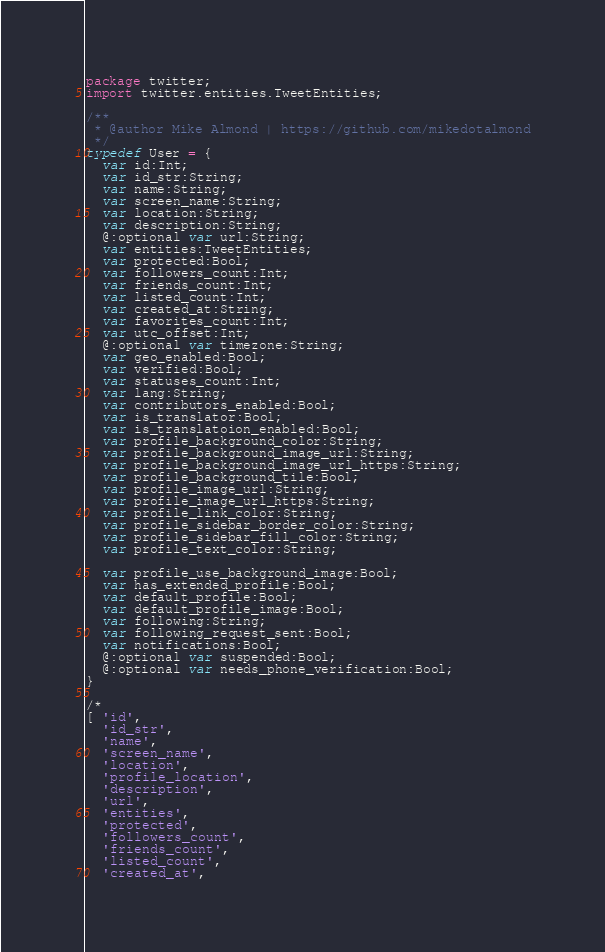<code> <loc_0><loc_0><loc_500><loc_500><_Haxe_>package twitter;
import twitter.entities.TweetEntities;

/**
 * @author Mike Almond | https://github.com/mikedotalmond
 */
typedef User = {
  var id:Int;
  var id_str:String;
  var name:String;
  var screen_name:String;
  var location:String;
  var description:String;
  @:optional var url:String;
  var entities:TweetEntities;
  var protected:Bool;
  var followers_count:Int;
  var friends_count:Int;
  var listed_count:Int;
  var created_at:String;
  var favorites_count:Int;
  var utc_offset:Int;
  @:optional var timezone:String;
  var geo_enabled:Bool;
  var verified:Bool;
  var statuses_count:Int;
  var lang:String;
  var contributors_enabled:Bool;
  var is_translator:Bool;
  var is_translatoion_enabled:Bool;
  var profile_background_color:String;
  var profile_background_image_url:String;
  var profile_background_image_url_https:String;
  var profile_background_tile:Bool;
  var profile_image_url:String;
  var profile_image_url_https:String;
  var profile_link_color:String;
  var profile_sidebar_border_color:String;
  var profile_sidebar_fill_color:String;
  var profile_text_color:String;
	
  var profile_use_background_image:Bool;
  var has_extended_profile:Bool;
  var default_profile:Bool;
  var default_profile_image:Bool;
  var following:String;
  var following_request_sent:Bool;
  var notifications:Bool;
  @:optional var suspended:Bool;
  @:optional var needs_phone_verification:Bool;
}

/*
[ 'id',
  'id_str',
  'name',
  'screen_name',
  'location',
  'profile_location',
  'description',
  'url',
  'entities',
  'protected',
  'followers_count',
  'friends_count',
  'listed_count',
  'created_at',</code> 